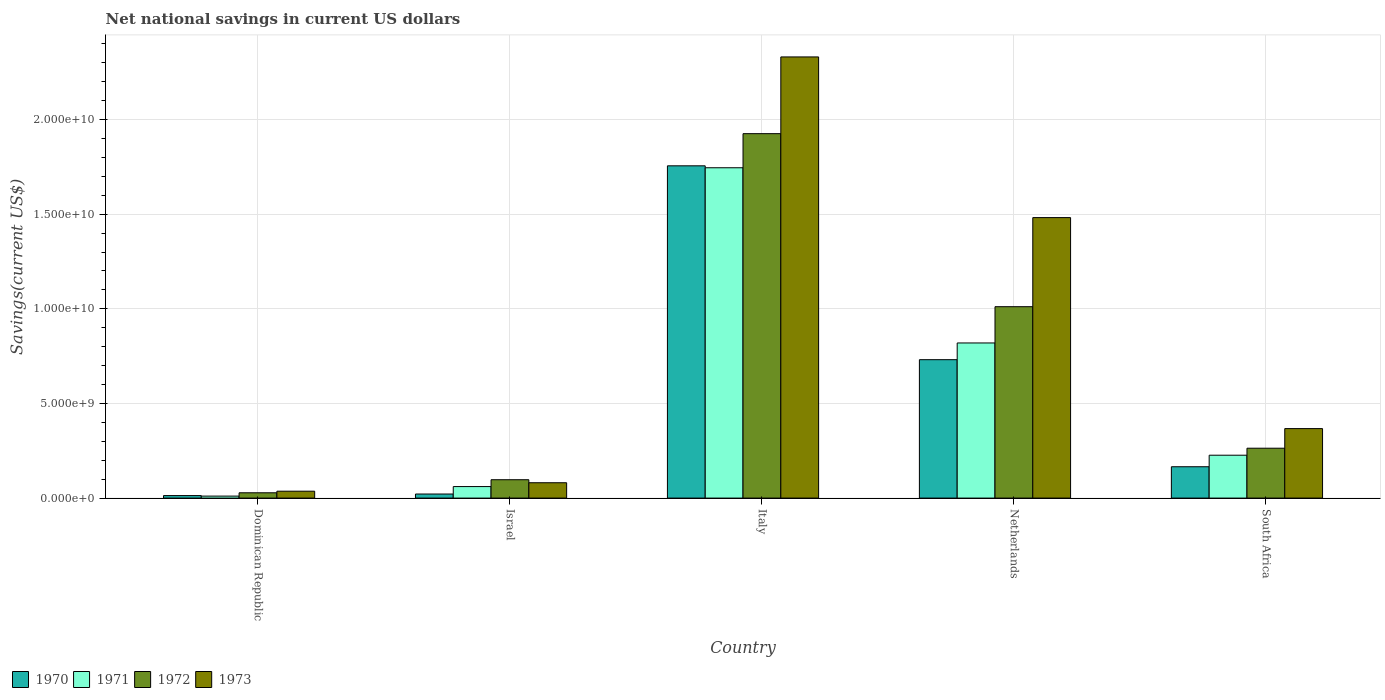What is the label of the 5th group of bars from the left?
Make the answer very short. South Africa. In how many cases, is the number of bars for a given country not equal to the number of legend labels?
Give a very brief answer. 0. What is the net national savings in 1970 in Netherlands?
Provide a short and direct response. 7.31e+09. Across all countries, what is the maximum net national savings in 1972?
Provide a short and direct response. 1.93e+1. Across all countries, what is the minimum net national savings in 1970?
Provide a short and direct response. 1.33e+08. In which country was the net national savings in 1972 minimum?
Ensure brevity in your answer.  Dominican Republic. What is the total net national savings in 1972 in the graph?
Give a very brief answer. 3.33e+1. What is the difference between the net national savings in 1972 in Israel and that in Netherlands?
Offer a very short reply. -9.14e+09. What is the difference between the net national savings in 1973 in Dominican Republic and the net national savings in 1971 in Italy?
Give a very brief answer. -1.71e+1. What is the average net national savings in 1970 per country?
Offer a very short reply. 5.37e+09. What is the difference between the net national savings of/in 1972 and net national savings of/in 1971 in South Africa?
Provide a short and direct response. 3.70e+08. In how many countries, is the net national savings in 1972 greater than 20000000000 US$?
Provide a short and direct response. 0. What is the ratio of the net national savings in 1973 in Israel to that in Netherlands?
Your answer should be very brief. 0.05. Is the net national savings in 1973 in Italy less than that in Netherlands?
Offer a terse response. No. What is the difference between the highest and the second highest net national savings in 1973?
Provide a short and direct response. -8.49e+09. What is the difference between the highest and the lowest net national savings in 1972?
Offer a very short reply. 1.90e+1. In how many countries, is the net national savings in 1972 greater than the average net national savings in 1972 taken over all countries?
Provide a succinct answer. 2. Is the sum of the net national savings in 1971 in Israel and Italy greater than the maximum net national savings in 1972 across all countries?
Provide a succinct answer. No. Is it the case that in every country, the sum of the net national savings in 1973 and net national savings in 1970 is greater than the sum of net national savings in 1972 and net national savings in 1971?
Your response must be concise. No. What does the 2nd bar from the right in Italy represents?
Your answer should be compact. 1972. Is it the case that in every country, the sum of the net national savings in 1971 and net national savings in 1973 is greater than the net national savings in 1972?
Keep it short and to the point. Yes. How many countries are there in the graph?
Offer a very short reply. 5. Does the graph contain grids?
Your answer should be very brief. Yes. How are the legend labels stacked?
Your answer should be very brief. Horizontal. What is the title of the graph?
Ensure brevity in your answer.  Net national savings in current US dollars. What is the label or title of the X-axis?
Ensure brevity in your answer.  Country. What is the label or title of the Y-axis?
Your answer should be very brief. Savings(current US$). What is the Savings(current US$) in 1970 in Dominican Republic?
Provide a succinct answer. 1.33e+08. What is the Savings(current US$) of 1971 in Dominican Republic?
Give a very brief answer. 1.05e+08. What is the Savings(current US$) of 1972 in Dominican Republic?
Your answer should be very brief. 2.80e+08. What is the Savings(current US$) of 1973 in Dominican Republic?
Provide a succinct answer. 3.65e+08. What is the Savings(current US$) in 1970 in Israel?
Offer a terse response. 2.15e+08. What is the Savings(current US$) of 1971 in Israel?
Provide a short and direct response. 6.09e+08. What is the Savings(current US$) in 1972 in Israel?
Ensure brevity in your answer.  9.71e+08. What is the Savings(current US$) in 1973 in Israel?
Ensure brevity in your answer.  8.11e+08. What is the Savings(current US$) of 1970 in Italy?
Keep it short and to the point. 1.76e+1. What is the Savings(current US$) in 1971 in Italy?
Make the answer very short. 1.75e+1. What is the Savings(current US$) of 1972 in Italy?
Ensure brevity in your answer.  1.93e+1. What is the Savings(current US$) in 1973 in Italy?
Your response must be concise. 2.33e+1. What is the Savings(current US$) in 1970 in Netherlands?
Ensure brevity in your answer.  7.31e+09. What is the Savings(current US$) in 1971 in Netherlands?
Give a very brief answer. 8.20e+09. What is the Savings(current US$) of 1972 in Netherlands?
Ensure brevity in your answer.  1.01e+1. What is the Savings(current US$) of 1973 in Netherlands?
Give a very brief answer. 1.48e+1. What is the Savings(current US$) of 1970 in South Africa?
Offer a terse response. 1.66e+09. What is the Savings(current US$) in 1971 in South Africa?
Your response must be concise. 2.27e+09. What is the Savings(current US$) of 1972 in South Africa?
Offer a very short reply. 2.64e+09. What is the Savings(current US$) of 1973 in South Africa?
Your response must be concise. 3.67e+09. Across all countries, what is the maximum Savings(current US$) of 1970?
Your answer should be compact. 1.76e+1. Across all countries, what is the maximum Savings(current US$) in 1971?
Provide a succinct answer. 1.75e+1. Across all countries, what is the maximum Savings(current US$) in 1972?
Ensure brevity in your answer.  1.93e+1. Across all countries, what is the maximum Savings(current US$) of 1973?
Give a very brief answer. 2.33e+1. Across all countries, what is the minimum Savings(current US$) in 1970?
Provide a short and direct response. 1.33e+08. Across all countries, what is the minimum Savings(current US$) in 1971?
Make the answer very short. 1.05e+08. Across all countries, what is the minimum Savings(current US$) of 1972?
Offer a terse response. 2.80e+08. Across all countries, what is the minimum Savings(current US$) in 1973?
Offer a terse response. 3.65e+08. What is the total Savings(current US$) of 1970 in the graph?
Your answer should be compact. 2.69e+1. What is the total Savings(current US$) of 1971 in the graph?
Keep it short and to the point. 2.86e+1. What is the total Savings(current US$) of 1972 in the graph?
Give a very brief answer. 3.33e+1. What is the total Savings(current US$) in 1973 in the graph?
Provide a short and direct response. 4.30e+1. What is the difference between the Savings(current US$) in 1970 in Dominican Republic and that in Israel?
Your answer should be very brief. -8.19e+07. What is the difference between the Savings(current US$) of 1971 in Dominican Republic and that in Israel?
Provide a short and direct response. -5.03e+08. What is the difference between the Savings(current US$) of 1972 in Dominican Republic and that in Israel?
Provide a succinct answer. -6.90e+08. What is the difference between the Savings(current US$) of 1973 in Dominican Republic and that in Israel?
Give a very brief answer. -4.46e+08. What is the difference between the Savings(current US$) of 1970 in Dominican Republic and that in Italy?
Ensure brevity in your answer.  -1.74e+1. What is the difference between the Savings(current US$) in 1971 in Dominican Republic and that in Italy?
Keep it short and to the point. -1.73e+1. What is the difference between the Savings(current US$) of 1972 in Dominican Republic and that in Italy?
Your answer should be very brief. -1.90e+1. What is the difference between the Savings(current US$) of 1973 in Dominican Republic and that in Italy?
Ensure brevity in your answer.  -2.29e+1. What is the difference between the Savings(current US$) of 1970 in Dominican Republic and that in Netherlands?
Provide a short and direct response. -7.18e+09. What is the difference between the Savings(current US$) of 1971 in Dominican Republic and that in Netherlands?
Give a very brief answer. -8.09e+09. What is the difference between the Savings(current US$) of 1972 in Dominican Republic and that in Netherlands?
Offer a terse response. -9.83e+09. What is the difference between the Savings(current US$) of 1973 in Dominican Republic and that in Netherlands?
Keep it short and to the point. -1.45e+1. What is the difference between the Savings(current US$) of 1970 in Dominican Republic and that in South Africa?
Your answer should be very brief. -1.52e+09. What is the difference between the Savings(current US$) in 1971 in Dominican Republic and that in South Africa?
Offer a very short reply. -2.16e+09. What is the difference between the Savings(current US$) in 1972 in Dominican Republic and that in South Africa?
Your answer should be very brief. -2.35e+09. What is the difference between the Savings(current US$) of 1973 in Dominican Republic and that in South Africa?
Provide a succinct answer. -3.31e+09. What is the difference between the Savings(current US$) of 1970 in Israel and that in Italy?
Make the answer very short. -1.73e+1. What is the difference between the Savings(current US$) of 1971 in Israel and that in Italy?
Provide a short and direct response. -1.68e+1. What is the difference between the Savings(current US$) in 1972 in Israel and that in Italy?
Your answer should be very brief. -1.83e+1. What is the difference between the Savings(current US$) of 1973 in Israel and that in Italy?
Offer a terse response. -2.25e+1. What is the difference between the Savings(current US$) in 1970 in Israel and that in Netherlands?
Offer a terse response. -7.10e+09. What is the difference between the Savings(current US$) of 1971 in Israel and that in Netherlands?
Give a very brief answer. -7.59e+09. What is the difference between the Savings(current US$) in 1972 in Israel and that in Netherlands?
Give a very brief answer. -9.14e+09. What is the difference between the Savings(current US$) in 1973 in Israel and that in Netherlands?
Give a very brief answer. -1.40e+1. What is the difference between the Savings(current US$) of 1970 in Israel and that in South Africa?
Provide a short and direct response. -1.44e+09. What is the difference between the Savings(current US$) of 1971 in Israel and that in South Africa?
Keep it short and to the point. -1.66e+09. What is the difference between the Savings(current US$) of 1972 in Israel and that in South Africa?
Provide a short and direct response. -1.66e+09. What is the difference between the Savings(current US$) in 1973 in Israel and that in South Africa?
Offer a terse response. -2.86e+09. What is the difference between the Savings(current US$) of 1970 in Italy and that in Netherlands?
Keep it short and to the point. 1.02e+1. What is the difference between the Savings(current US$) in 1971 in Italy and that in Netherlands?
Keep it short and to the point. 9.26e+09. What is the difference between the Savings(current US$) of 1972 in Italy and that in Netherlands?
Give a very brief answer. 9.14e+09. What is the difference between the Savings(current US$) in 1973 in Italy and that in Netherlands?
Provide a short and direct response. 8.49e+09. What is the difference between the Savings(current US$) in 1970 in Italy and that in South Africa?
Offer a terse response. 1.59e+1. What is the difference between the Savings(current US$) in 1971 in Italy and that in South Africa?
Provide a short and direct response. 1.52e+1. What is the difference between the Savings(current US$) in 1972 in Italy and that in South Africa?
Make the answer very short. 1.66e+1. What is the difference between the Savings(current US$) of 1973 in Italy and that in South Africa?
Provide a succinct answer. 1.96e+1. What is the difference between the Savings(current US$) in 1970 in Netherlands and that in South Africa?
Keep it short and to the point. 5.66e+09. What is the difference between the Savings(current US$) in 1971 in Netherlands and that in South Africa?
Your response must be concise. 5.93e+09. What is the difference between the Savings(current US$) of 1972 in Netherlands and that in South Africa?
Your answer should be very brief. 7.48e+09. What is the difference between the Savings(current US$) in 1973 in Netherlands and that in South Africa?
Give a very brief answer. 1.11e+1. What is the difference between the Savings(current US$) in 1970 in Dominican Republic and the Savings(current US$) in 1971 in Israel?
Make the answer very short. -4.76e+08. What is the difference between the Savings(current US$) in 1970 in Dominican Republic and the Savings(current US$) in 1972 in Israel?
Your answer should be compact. -8.38e+08. What is the difference between the Savings(current US$) in 1970 in Dominican Republic and the Savings(current US$) in 1973 in Israel?
Offer a very short reply. -6.78e+08. What is the difference between the Savings(current US$) of 1971 in Dominican Republic and the Savings(current US$) of 1972 in Israel?
Provide a succinct answer. -8.65e+08. What is the difference between the Savings(current US$) of 1971 in Dominican Republic and the Savings(current US$) of 1973 in Israel?
Keep it short and to the point. -7.05e+08. What is the difference between the Savings(current US$) in 1972 in Dominican Republic and the Savings(current US$) in 1973 in Israel?
Provide a succinct answer. -5.30e+08. What is the difference between the Savings(current US$) in 1970 in Dominican Republic and the Savings(current US$) in 1971 in Italy?
Your answer should be very brief. -1.73e+1. What is the difference between the Savings(current US$) of 1970 in Dominican Republic and the Savings(current US$) of 1972 in Italy?
Offer a very short reply. -1.91e+1. What is the difference between the Savings(current US$) of 1970 in Dominican Republic and the Savings(current US$) of 1973 in Italy?
Your response must be concise. -2.32e+1. What is the difference between the Savings(current US$) of 1971 in Dominican Republic and the Savings(current US$) of 1972 in Italy?
Ensure brevity in your answer.  -1.91e+1. What is the difference between the Savings(current US$) of 1971 in Dominican Republic and the Savings(current US$) of 1973 in Italy?
Offer a terse response. -2.32e+1. What is the difference between the Savings(current US$) in 1972 in Dominican Republic and the Savings(current US$) in 1973 in Italy?
Offer a terse response. -2.30e+1. What is the difference between the Savings(current US$) in 1970 in Dominican Republic and the Savings(current US$) in 1971 in Netherlands?
Ensure brevity in your answer.  -8.06e+09. What is the difference between the Savings(current US$) of 1970 in Dominican Republic and the Savings(current US$) of 1972 in Netherlands?
Offer a terse response. -9.98e+09. What is the difference between the Savings(current US$) in 1970 in Dominican Republic and the Savings(current US$) in 1973 in Netherlands?
Ensure brevity in your answer.  -1.47e+1. What is the difference between the Savings(current US$) in 1971 in Dominican Republic and the Savings(current US$) in 1972 in Netherlands?
Ensure brevity in your answer.  -1.00e+1. What is the difference between the Savings(current US$) of 1971 in Dominican Republic and the Savings(current US$) of 1973 in Netherlands?
Keep it short and to the point. -1.47e+1. What is the difference between the Savings(current US$) of 1972 in Dominican Republic and the Savings(current US$) of 1973 in Netherlands?
Make the answer very short. -1.45e+1. What is the difference between the Savings(current US$) in 1970 in Dominican Republic and the Savings(current US$) in 1971 in South Africa?
Your response must be concise. -2.13e+09. What is the difference between the Savings(current US$) in 1970 in Dominican Republic and the Savings(current US$) in 1972 in South Africa?
Offer a terse response. -2.50e+09. What is the difference between the Savings(current US$) in 1970 in Dominican Republic and the Savings(current US$) in 1973 in South Africa?
Your response must be concise. -3.54e+09. What is the difference between the Savings(current US$) in 1971 in Dominican Republic and the Savings(current US$) in 1972 in South Africa?
Your response must be concise. -2.53e+09. What is the difference between the Savings(current US$) of 1971 in Dominican Republic and the Savings(current US$) of 1973 in South Africa?
Your answer should be compact. -3.57e+09. What is the difference between the Savings(current US$) in 1972 in Dominican Republic and the Savings(current US$) in 1973 in South Africa?
Keep it short and to the point. -3.39e+09. What is the difference between the Savings(current US$) of 1970 in Israel and the Savings(current US$) of 1971 in Italy?
Provide a succinct answer. -1.72e+1. What is the difference between the Savings(current US$) of 1970 in Israel and the Savings(current US$) of 1972 in Italy?
Keep it short and to the point. -1.90e+1. What is the difference between the Savings(current US$) in 1970 in Israel and the Savings(current US$) in 1973 in Italy?
Make the answer very short. -2.31e+1. What is the difference between the Savings(current US$) in 1971 in Israel and the Savings(current US$) in 1972 in Italy?
Provide a succinct answer. -1.86e+1. What is the difference between the Savings(current US$) in 1971 in Israel and the Savings(current US$) in 1973 in Italy?
Provide a short and direct response. -2.27e+1. What is the difference between the Savings(current US$) of 1972 in Israel and the Savings(current US$) of 1973 in Italy?
Your answer should be very brief. -2.23e+1. What is the difference between the Savings(current US$) of 1970 in Israel and the Savings(current US$) of 1971 in Netherlands?
Ensure brevity in your answer.  -7.98e+09. What is the difference between the Savings(current US$) in 1970 in Israel and the Savings(current US$) in 1972 in Netherlands?
Provide a succinct answer. -9.90e+09. What is the difference between the Savings(current US$) in 1970 in Israel and the Savings(current US$) in 1973 in Netherlands?
Give a very brief answer. -1.46e+1. What is the difference between the Savings(current US$) of 1971 in Israel and the Savings(current US$) of 1972 in Netherlands?
Offer a very short reply. -9.50e+09. What is the difference between the Savings(current US$) in 1971 in Israel and the Savings(current US$) in 1973 in Netherlands?
Keep it short and to the point. -1.42e+1. What is the difference between the Savings(current US$) in 1972 in Israel and the Savings(current US$) in 1973 in Netherlands?
Provide a short and direct response. -1.38e+1. What is the difference between the Savings(current US$) of 1970 in Israel and the Savings(current US$) of 1971 in South Africa?
Your answer should be very brief. -2.05e+09. What is the difference between the Savings(current US$) of 1970 in Israel and the Savings(current US$) of 1972 in South Africa?
Your answer should be compact. -2.42e+09. What is the difference between the Savings(current US$) in 1970 in Israel and the Savings(current US$) in 1973 in South Africa?
Provide a succinct answer. -3.46e+09. What is the difference between the Savings(current US$) in 1971 in Israel and the Savings(current US$) in 1972 in South Africa?
Your answer should be compact. -2.03e+09. What is the difference between the Savings(current US$) of 1971 in Israel and the Savings(current US$) of 1973 in South Africa?
Ensure brevity in your answer.  -3.06e+09. What is the difference between the Savings(current US$) in 1972 in Israel and the Savings(current US$) in 1973 in South Africa?
Offer a very short reply. -2.70e+09. What is the difference between the Savings(current US$) of 1970 in Italy and the Savings(current US$) of 1971 in Netherlands?
Your answer should be compact. 9.36e+09. What is the difference between the Savings(current US$) of 1970 in Italy and the Savings(current US$) of 1972 in Netherlands?
Keep it short and to the point. 7.44e+09. What is the difference between the Savings(current US$) in 1970 in Italy and the Savings(current US$) in 1973 in Netherlands?
Provide a short and direct response. 2.74e+09. What is the difference between the Savings(current US$) of 1971 in Italy and the Savings(current US$) of 1972 in Netherlands?
Offer a terse response. 7.34e+09. What is the difference between the Savings(current US$) of 1971 in Italy and the Savings(current US$) of 1973 in Netherlands?
Your response must be concise. 2.63e+09. What is the difference between the Savings(current US$) of 1972 in Italy and the Savings(current US$) of 1973 in Netherlands?
Make the answer very short. 4.44e+09. What is the difference between the Savings(current US$) of 1970 in Italy and the Savings(current US$) of 1971 in South Africa?
Give a very brief answer. 1.53e+1. What is the difference between the Savings(current US$) of 1970 in Italy and the Savings(current US$) of 1972 in South Africa?
Offer a very short reply. 1.49e+1. What is the difference between the Savings(current US$) of 1970 in Italy and the Savings(current US$) of 1973 in South Africa?
Offer a very short reply. 1.39e+1. What is the difference between the Savings(current US$) in 1971 in Italy and the Savings(current US$) in 1972 in South Africa?
Provide a short and direct response. 1.48e+1. What is the difference between the Savings(current US$) in 1971 in Italy and the Savings(current US$) in 1973 in South Africa?
Ensure brevity in your answer.  1.38e+1. What is the difference between the Savings(current US$) of 1972 in Italy and the Savings(current US$) of 1973 in South Africa?
Give a very brief answer. 1.56e+1. What is the difference between the Savings(current US$) in 1970 in Netherlands and the Savings(current US$) in 1971 in South Africa?
Your response must be concise. 5.05e+09. What is the difference between the Savings(current US$) in 1970 in Netherlands and the Savings(current US$) in 1972 in South Africa?
Give a very brief answer. 4.68e+09. What is the difference between the Savings(current US$) of 1970 in Netherlands and the Savings(current US$) of 1973 in South Africa?
Provide a succinct answer. 3.64e+09. What is the difference between the Savings(current US$) in 1971 in Netherlands and the Savings(current US$) in 1972 in South Africa?
Provide a succinct answer. 5.56e+09. What is the difference between the Savings(current US$) in 1971 in Netherlands and the Savings(current US$) in 1973 in South Africa?
Ensure brevity in your answer.  4.52e+09. What is the difference between the Savings(current US$) in 1972 in Netherlands and the Savings(current US$) in 1973 in South Africa?
Keep it short and to the point. 6.44e+09. What is the average Savings(current US$) in 1970 per country?
Offer a very short reply. 5.37e+09. What is the average Savings(current US$) in 1971 per country?
Your answer should be very brief. 5.73e+09. What is the average Savings(current US$) of 1972 per country?
Provide a short and direct response. 6.65e+09. What is the average Savings(current US$) of 1973 per country?
Offer a very short reply. 8.59e+09. What is the difference between the Savings(current US$) in 1970 and Savings(current US$) in 1971 in Dominican Republic?
Offer a very short reply. 2.74e+07. What is the difference between the Savings(current US$) of 1970 and Savings(current US$) of 1972 in Dominican Republic?
Provide a succinct answer. -1.48e+08. What is the difference between the Savings(current US$) in 1970 and Savings(current US$) in 1973 in Dominican Republic?
Your response must be concise. -2.32e+08. What is the difference between the Savings(current US$) of 1971 and Savings(current US$) of 1972 in Dominican Republic?
Keep it short and to the point. -1.75e+08. What is the difference between the Savings(current US$) of 1971 and Savings(current US$) of 1973 in Dominican Republic?
Offer a terse response. -2.59e+08. What is the difference between the Savings(current US$) of 1972 and Savings(current US$) of 1973 in Dominican Republic?
Ensure brevity in your answer.  -8.40e+07. What is the difference between the Savings(current US$) in 1970 and Savings(current US$) in 1971 in Israel?
Offer a very short reply. -3.94e+08. What is the difference between the Savings(current US$) in 1970 and Savings(current US$) in 1972 in Israel?
Your response must be concise. -7.56e+08. What is the difference between the Savings(current US$) of 1970 and Savings(current US$) of 1973 in Israel?
Your response must be concise. -5.96e+08. What is the difference between the Savings(current US$) in 1971 and Savings(current US$) in 1972 in Israel?
Make the answer very short. -3.62e+08. What is the difference between the Savings(current US$) in 1971 and Savings(current US$) in 1973 in Israel?
Provide a succinct answer. -2.02e+08. What is the difference between the Savings(current US$) of 1972 and Savings(current US$) of 1973 in Israel?
Make the answer very short. 1.60e+08. What is the difference between the Savings(current US$) in 1970 and Savings(current US$) in 1971 in Italy?
Provide a succinct answer. 1.03e+08. What is the difference between the Savings(current US$) of 1970 and Savings(current US$) of 1972 in Italy?
Make the answer very short. -1.70e+09. What is the difference between the Savings(current US$) in 1970 and Savings(current US$) in 1973 in Italy?
Your answer should be very brief. -5.75e+09. What is the difference between the Savings(current US$) in 1971 and Savings(current US$) in 1972 in Italy?
Provide a short and direct response. -1.80e+09. What is the difference between the Savings(current US$) in 1971 and Savings(current US$) in 1973 in Italy?
Your answer should be compact. -5.86e+09. What is the difference between the Savings(current US$) of 1972 and Savings(current US$) of 1973 in Italy?
Keep it short and to the point. -4.05e+09. What is the difference between the Savings(current US$) in 1970 and Savings(current US$) in 1971 in Netherlands?
Make the answer very short. -8.83e+08. What is the difference between the Savings(current US$) of 1970 and Savings(current US$) of 1972 in Netherlands?
Give a very brief answer. -2.80e+09. What is the difference between the Savings(current US$) of 1970 and Savings(current US$) of 1973 in Netherlands?
Provide a short and direct response. -7.51e+09. What is the difference between the Savings(current US$) in 1971 and Savings(current US$) in 1972 in Netherlands?
Keep it short and to the point. -1.92e+09. What is the difference between the Savings(current US$) of 1971 and Savings(current US$) of 1973 in Netherlands?
Provide a short and direct response. -6.62e+09. What is the difference between the Savings(current US$) in 1972 and Savings(current US$) in 1973 in Netherlands?
Your response must be concise. -4.71e+09. What is the difference between the Savings(current US$) in 1970 and Savings(current US$) in 1971 in South Africa?
Your answer should be compact. -6.09e+08. What is the difference between the Savings(current US$) of 1970 and Savings(current US$) of 1972 in South Africa?
Ensure brevity in your answer.  -9.79e+08. What is the difference between the Savings(current US$) of 1970 and Savings(current US$) of 1973 in South Africa?
Your answer should be compact. -2.02e+09. What is the difference between the Savings(current US$) in 1971 and Savings(current US$) in 1972 in South Africa?
Your response must be concise. -3.70e+08. What is the difference between the Savings(current US$) of 1971 and Savings(current US$) of 1973 in South Africa?
Make the answer very short. -1.41e+09. What is the difference between the Savings(current US$) in 1972 and Savings(current US$) in 1973 in South Africa?
Make the answer very short. -1.04e+09. What is the ratio of the Savings(current US$) of 1970 in Dominican Republic to that in Israel?
Offer a terse response. 0.62. What is the ratio of the Savings(current US$) in 1971 in Dominican Republic to that in Israel?
Offer a terse response. 0.17. What is the ratio of the Savings(current US$) in 1972 in Dominican Republic to that in Israel?
Your answer should be compact. 0.29. What is the ratio of the Savings(current US$) in 1973 in Dominican Republic to that in Israel?
Make the answer very short. 0.45. What is the ratio of the Savings(current US$) of 1970 in Dominican Republic to that in Italy?
Give a very brief answer. 0.01. What is the ratio of the Savings(current US$) of 1971 in Dominican Republic to that in Italy?
Offer a very short reply. 0.01. What is the ratio of the Savings(current US$) of 1972 in Dominican Republic to that in Italy?
Your answer should be very brief. 0.01. What is the ratio of the Savings(current US$) in 1973 in Dominican Republic to that in Italy?
Provide a short and direct response. 0.02. What is the ratio of the Savings(current US$) of 1970 in Dominican Republic to that in Netherlands?
Offer a terse response. 0.02. What is the ratio of the Savings(current US$) of 1971 in Dominican Republic to that in Netherlands?
Offer a very short reply. 0.01. What is the ratio of the Savings(current US$) in 1972 in Dominican Republic to that in Netherlands?
Your answer should be compact. 0.03. What is the ratio of the Savings(current US$) of 1973 in Dominican Republic to that in Netherlands?
Your answer should be compact. 0.02. What is the ratio of the Savings(current US$) in 1970 in Dominican Republic to that in South Africa?
Keep it short and to the point. 0.08. What is the ratio of the Savings(current US$) in 1971 in Dominican Republic to that in South Africa?
Keep it short and to the point. 0.05. What is the ratio of the Savings(current US$) in 1972 in Dominican Republic to that in South Africa?
Offer a very short reply. 0.11. What is the ratio of the Savings(current US$) of 1973 in Dominican Republic to that in South Africa?
Give a very brief answer. 0.1. What is the ratio of the Savings(current US$) in 1970 in Israel to that in Italy?
Make the answer very short. 0.01. What is the ratio of the Savings(current US$) in 1971 in Israel to that in Italy?
Keep it short and to the point. 0.03. What is the ratio of the Savings(current US$) in 1972 in Israel to that in Italy?
Provide a succinct answer. 0.05. What is the ratio of the Savings(current US$) in 1973 in Israel to that in Italy?
Offer a terse response. 0.03. What is the ratio of the Savings(current US$) in 1970 in Israel to that in Netherlands?
Offer a very short reply. 0.03. What is the ratio of the Savings(current US$) of 1971 in Israel to that in Netherlands?
Offer a terse response. 0.07. What is the ratio of the Savings(current US$) in 1972 in Israel to that in Netherlands?
Provide a succinct answer. 0.1. What is the ratio of the Savings(current US$) in 1973 in Israel to that in Netherlands?
Your answer should be very brief. 0.05. What is the ratio of the Savings(current US$) in 1970 in Israel to that in South Africa?
Provide a succinct answer. 0.13. What is the ratio of the Savings(current US$) in 1971 in Israel to that in South Africa?
Provide a succinct answer. 0.27. What is the ratio of the Savings(current US$) of 1972 in Israel to that in South Africa?
Ensure brevity in your answer.  0.37. What is the ratio of the Savings(current US$) of 1973 in Israel to that in South Africa?
Provide a succinct answer. 0.22. What is the ratio of the Savings(current US$) of 1970 in Italy to that in Netherlands?
Keep it short and to the point. 2.4. What is the ratio of the Savings(current US$) in 1971 in Italy to that in Netherlands?
Provide a succinct answer. 2.13. What is the ratio of the Savings(current US$) in 1972 in Italy to that in Netherlands?
Provide a succinct answer. 1.9. What is the ratio of the Savings(current US$) in 1973 in Italy to that in Netherlands?
Your answer should be very brief. 1.57. What is the ratio of the Savings(current US$) of 1970 in Italy to that in South Africa?
Provide a short and direct response. 10.6. What is the ratio of the Savings(current US$) of 1971 in Italy to that in South Africa?
Provide a short and direct response. 7.7. What is the ratio of the Savings(current US$) of 1972 in Italy to that in South Africa?
Offer a very short reply. 7.31. What is the ratio of the Savings(current US$) of 1973 in Italy to that in South Africa?
Your answer should be compact. 6.35. What is the ratio of the Savings(current US$) of 1970 in Netherlands to that in South Africa?
Provide a succinct answer. 4.42. What is the ratio of the Savings(current US$) in 1971 in Netherlands to that in South Africa?
Your response must be concise. 3.62. What is the ratio of the Savings(current US$) of 1972 in Netherlands to that in South Africa?
Offer a terse response. 3.84. What is the ratio of the Savings(current US$) in 1973 in Netherlands to that in South Africa?
Offer a terse response. 4.04. What is the difference between the highest and the second highest Savings(current US$) of 1970?
Offer a terse response. 1.02e+1. What is the difference between the highest and the second highest Savings(current US$) of 1971?
Your answer should be compact. 9.26e+09. What is the difference between the highest and the second highest Savings(current US$) of 1972?
Your response must be concise. 9.14e+09. What is the difference between the highest and the second highest Savings(current US$) in 1973?
Give a very brief answer. 8.49e+09. What is the difference between the highest and the lowest Savings(current US$) in 1970?
Your answer should be very brief. 1.74e+1. What is the difference between the highest and the lowest Savings(current US$) in 1971?
Offer a terse response. 1.73e+1. What is the difference between the highest and the lowest Savings(current US$) in 1972?
Provide a short and direct response. 1.90e+1. What is the difference between the highest and the lowest Savings(current US$) of 1973?
Your response must be concise. 2.29e+1. 